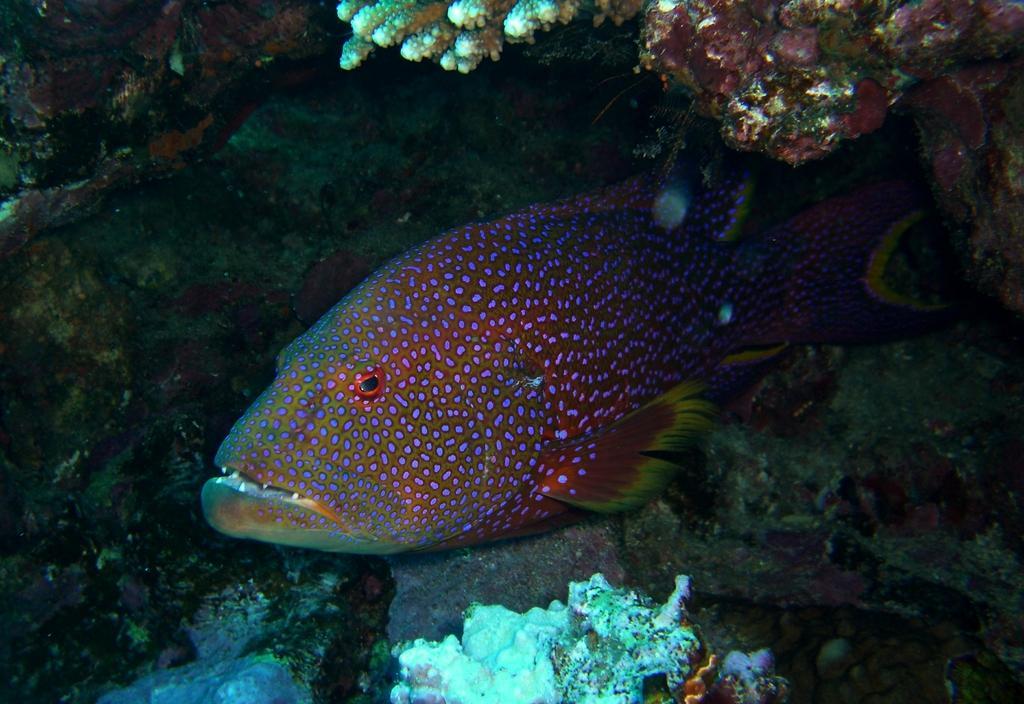Describe this image in one or two sentences. In this image we can see a fish swimming in the water. 